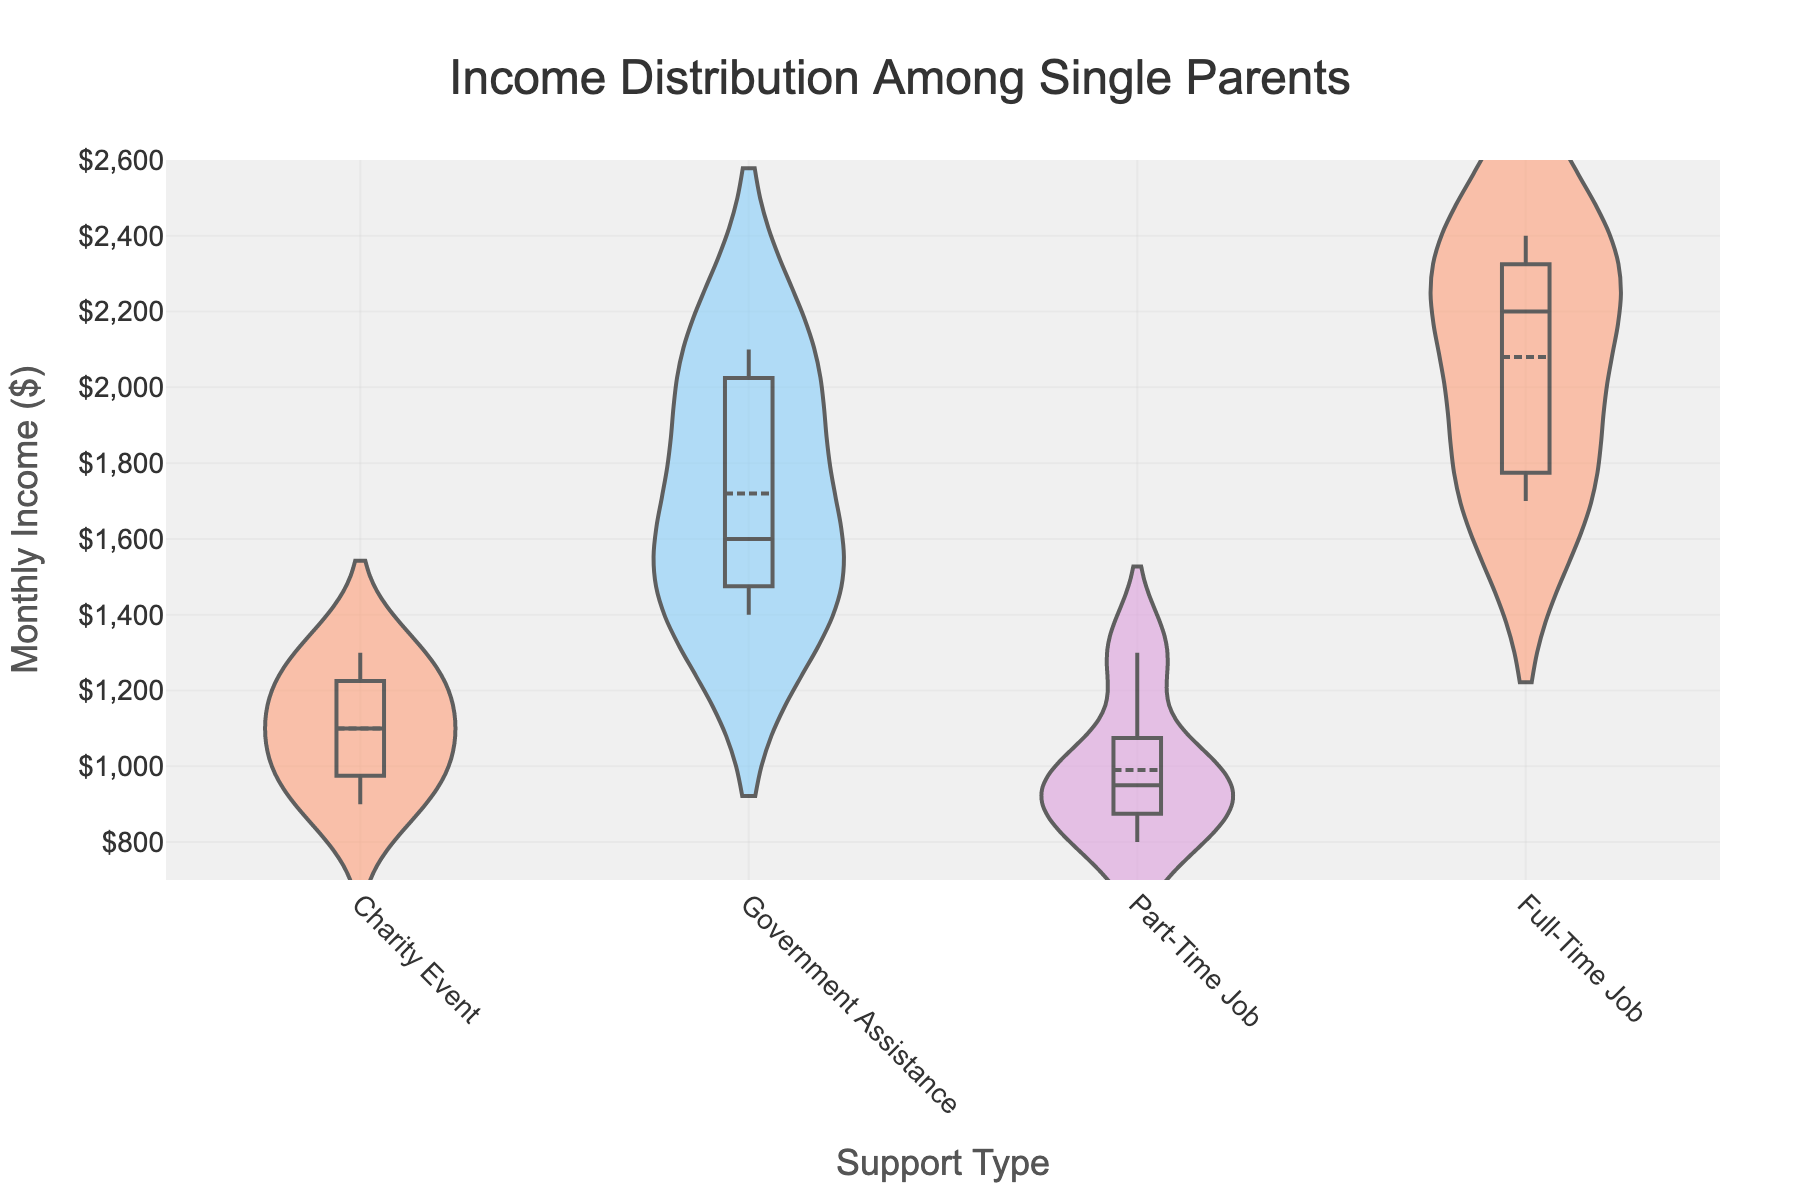What is the title of the figure? The title is usually located at the top of the chart and is clearly labeled to describe what the chart represents. In this case, it is directly shown on the chart header.
Answer: Income Distribution Among Single Parents Which support type has the highest median monthly income? To find the highest median, look at the middle line within the box plot overlay within each violin plot. Compare the medians across support types.
Answer: Full-Time Job What’s the range of the y-axis? The range of the y-axis is determined by the minimum and maximum values shown on the axis. The chart clearly marks these boundaries.
Answer: $700 to $2600 How many support types are displayed in the figure? The number of categories on the x-axis represents the different support types. Count each unique label on the x-axis.
Answer: 4 Which support type shows the most variability in monthly income? To determine variability, observe the width and spread of each violin plot. The wider and more spread out the plot, the more variability it shows.
Answer: Full-Time Job What is the lowest monthly income shown by the box plot overlay for charity events? Within the box plot overlay for Charity Event, identify the bottom whisker, which represents the lowest data point within the range (excluding outliers).
Answer: $900 Which support type has the smallest interquartile range (IQR)? The IQR is represented by the height of the box in the box plot overlay. Compare the height of the boxes across the support types.
Answer: Government Assistance Is the mean monthly income of part-time jobs higher or lower than the mean monthly income of government assistance? Look at the mean line within the box plot overlay for both Part-Time Job and Government Assistance. Compare their positions.
Answer: Lower What is the mean monthly income for full-time jobs displayed on the chart? The mean is shown by the small horizontal line within the box of the box plot overlay specifically for Full-Time Job.
Answer: Approximately $2050 Between which two support types is the difference in median monthly income the greatest? Identify the median (middle line in the box) for each support type. Calculate the differences between medians, and find the greatest one.
Answer: Full-Time Job and Part-Time Job 